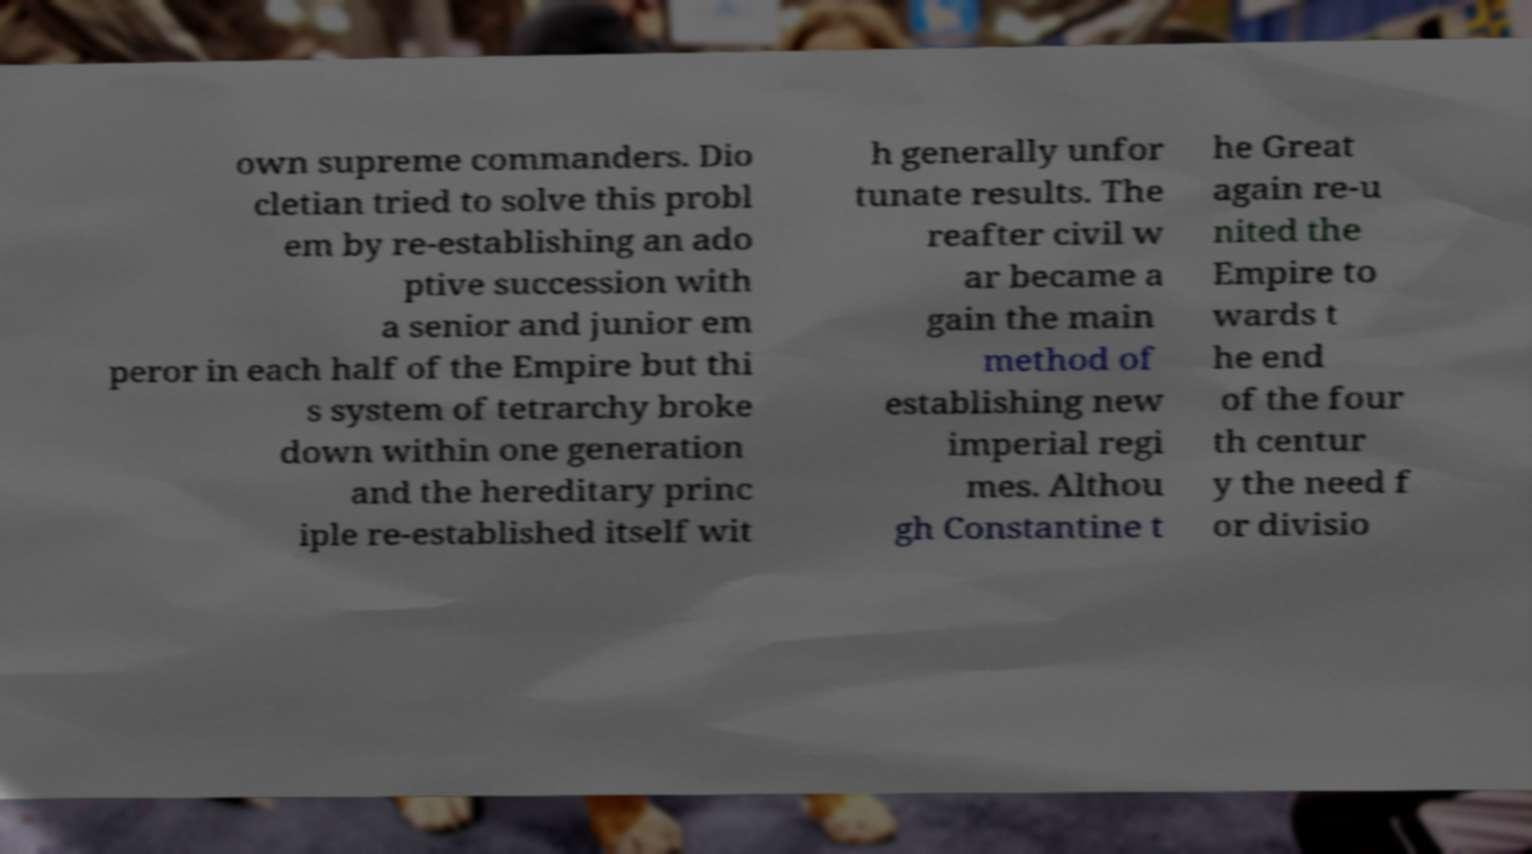For documentation purposes, I need the text within this image transcribed. Could you provide that? own supreme commanders. Dio cletian tried to solve this probl em by re-establishing an ado ptive succession with a senior and junior em peror in each half of the Empire but thi s system of tetrarchy broke down within one generation and the hereditary princ iple re-established itself wit h generally unfor tunate results. The reafter civil w ar became a gain the main method of establishing new imperial regi mes. Althou gh Constantine t he Great again re-u nited the Empire to wards t he end of the four th centur y the need f or divisio 